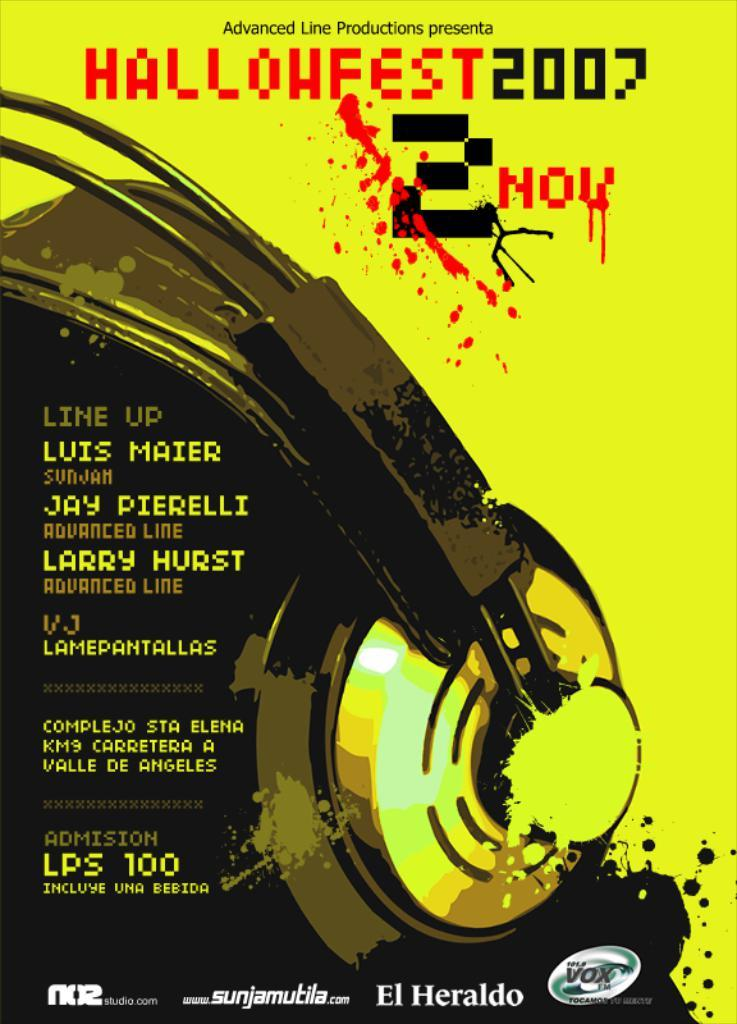<image>
Describe the image concisely. A yellow poster for Hallohfest 2007 with a line up to include Luis Maier. 